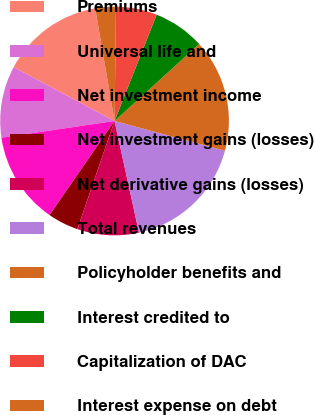<chart> <loc_0><loc_0><loc_500><loc_500><pie_chart><fcel>Premiums<fcel>Universal life and<fcel>Net investment income<fcel>Net investment gains (losses)<fcel>Net derivative gains (losses)<fcel>Total revenues<fcel>Policyholder benefits and<fcel>Interest credited to<fcel>Capitalization of DAC<fcel>Interest expense on debt<nl><fcel>14.49%<fcel>10.14%<fcel>13.04%<fcel>4.35%<fcel>8.7%<fcel>17.38%<fcel>15.94%<fcel>7.25%<fcel>5.8%<fcel>2.91%<nl></chart> 